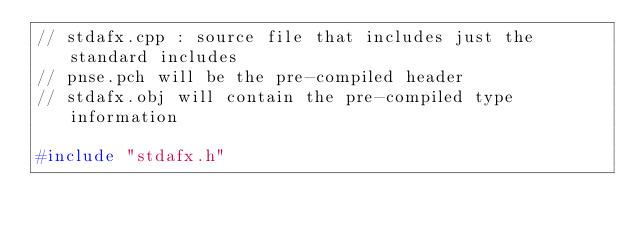<code> <loc_0><loc_0><loc_500><loc_500><_C++_>// stdafx.cpp : source file that includes just the standard includes
// pnse.pch will be the pre-compiled header
// stdafx.obj will contain the pre-compiled type information

#include "stdafx.h"
</code> 